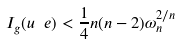<formula> <loc_0><loc_0><loc_500><loc_500>I _ { g } ( u _ { \ } e ) < \frac { 1 } { 4 } n ( n - 2 ) \omega _ { n } ^ { 2 / n }</formula> 